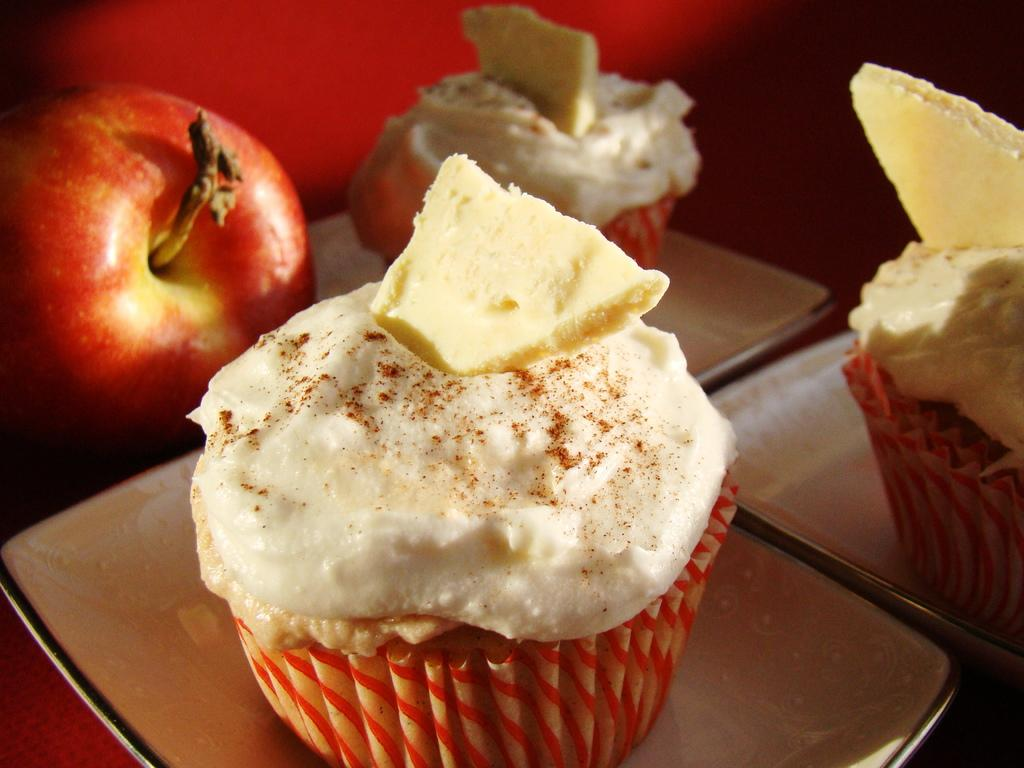What is on the plate that is visible in the image? There is a cupcake on a plate in the image. Where is the plate with the cupcake located? The plate with the cupcake is placed on a table. What other fruit can be seen in the image besides the cupcake? There is an apple on the left side of the image. How many eggs are being used by the laborer in the image? There is no laborer or eggs present in the image. 